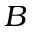Convert formula to latex. <formula><loc_0><loc_0><loc_500><loc_500>B</formula> 